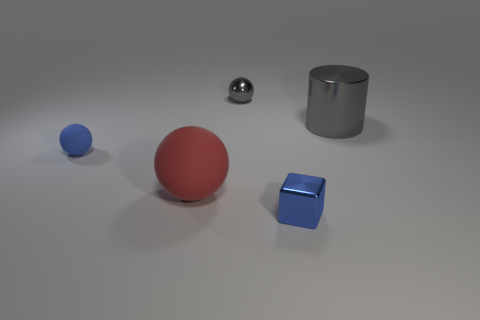What is the material of the tiny thing that is the same color as the cylinder?
Give a very brief answer. Metal. What is the color of the small thing on the left side of the gray metal thing behind the big thing that is to the right of the small blue metallic thing?
Provide a short and direct response. Blue. How many big things are blue metal objects or red matte objects?
Your response must be concise. 1. Is the number of small metal things that are behind the big cylinder the same as the number of large green metallic cubes?
Your answer should be very brief. No. There is a small metal block; are there any gray objects right of it?
Keep it short and to the point. Yes. What number of shiny objects are either small purple spheres or gray objects?
Provide a short and direct response. 2. There is a big cylinder; how many small things are to the right of it?
Provide a short and direct response. 0. Are there any cylinders that have the same size as the red object?
Your answer should be compact. Yes. Is there a small ball that has the same color as the block?
Provide a succinct answer. Yes. What number of tiny shiny objects have the same color as the large metal object?
Provide a succinct answer. 1. 